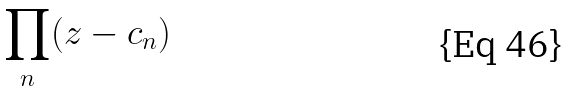Convert formula to latex. <formula><loc_0><loc_0><loc_500><loc_500>\prod _ { n } ( z - c _ { n } )</formula> 